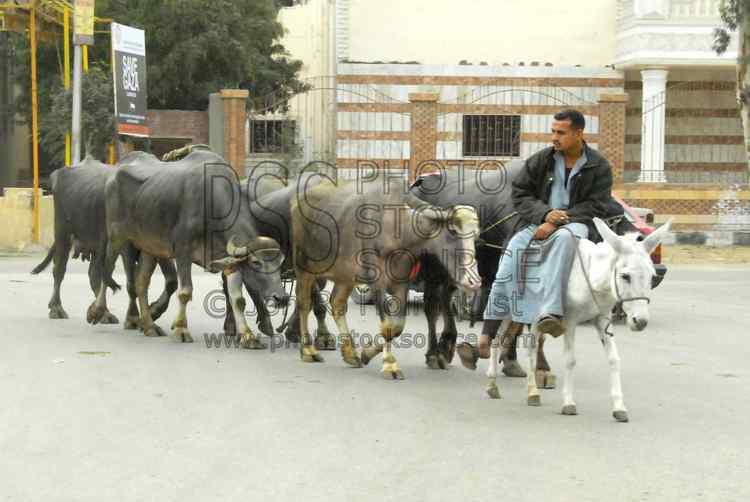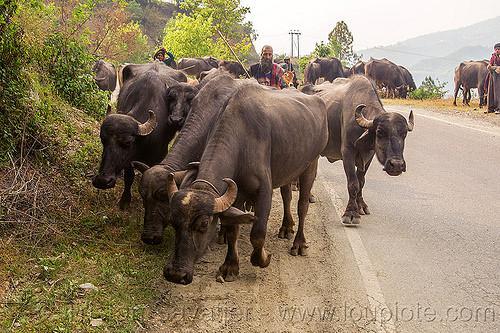The first image is the image on the left, the second image is the image on the right. Evaluate the accuracy of this statement regarding the images: "Each image shows a group of cattle-type animals walking down a path, and the right image shows a man holding a stick walking behind some of them.". Is it true? Answer yes or no. Yes. 